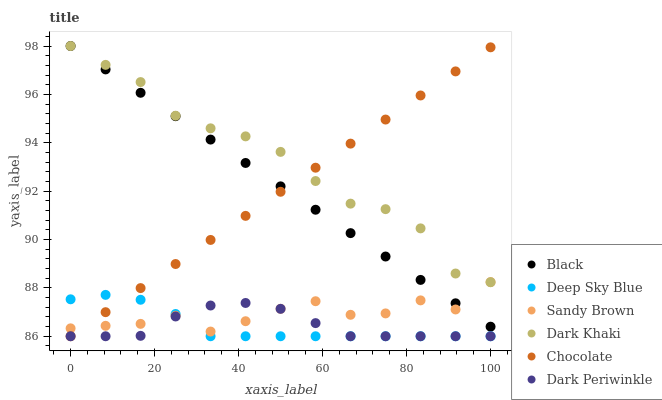Does Deep Sky Blue have the minimum area under the curve?
Answer yes or no. Yes. Does Dark Khaki have the maximum area under the curve?
Answer yes or no. Yes. Does Black have the minimum area under the curve?
Answer yes or no. No. Does Black have the maximum area under the curve?
Answer yes or no. No. Is Chocolate the smoothest?
Answer yes or no. Yes. Is Sandy Brown the roughest?
Answer yes or no. Yes. Is Dark Khaki the smoothest?
Answer yes or no. No. Is Dark Khaki the roughest?
Answer yes or no. No. Does Chocolate have the lowest value?
Answer yes or no. Yes. Does Black have the lowest value?
Answer yes or no. No. Does Black have the highest value?
Answer yes or no. Yes. Does Deep Sky Blue have the highest value?
Answer yes or no. No. Is Dark Periwinkle less than Black?
Answer yes or no. Yes. Is Black greater than Dark Periwinkle?
Answer yes or no. Yes. Does Black intersect Chocolate?
Answer yes or no. Yes. Is Black less than Chocolate?
Answer yes or no. No. Is Black greater than Chocolate?
Answer yes or no. No. Does Dark Periwinkle intersect Black?
Answer yes or no. No. 